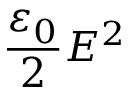Convert formula to latex. <formula><loc_0><loc_0><loc_500><loc_500>{ \frac { \varepsilon _ { 0 } } { 2 } } E ^ { 2 }</formula> 